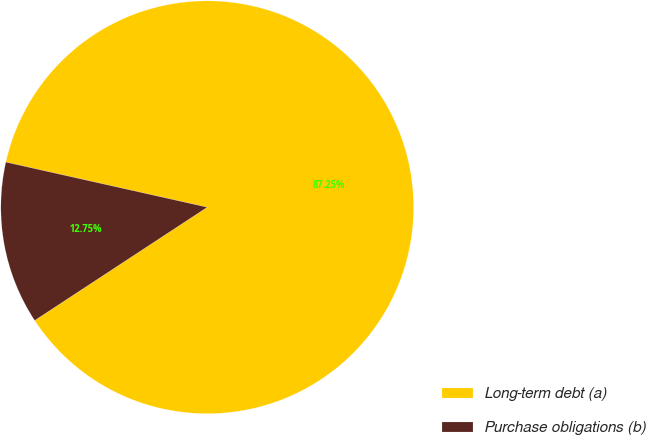<chart> <loc_0><loc_0><loc_500><loc_500><pie_chart><fcel>Long-term debt (a)<fcel>Purchase obligations (b)<nl><fcel>87.25%<fcel>12.75%<nl></chart> 